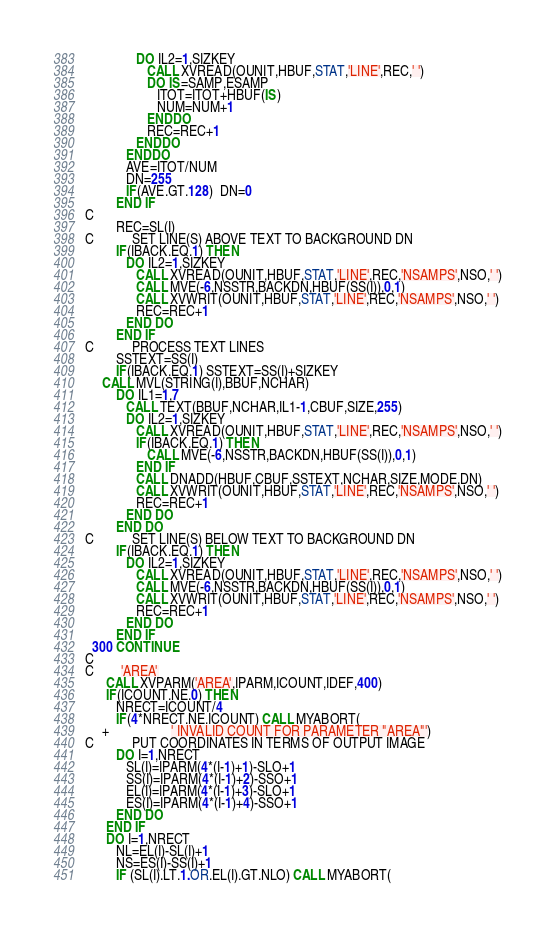<code> <loc_0><loc_0><loc_500><loc_500><_FORTRAN_>               DO IL2=1,SIZKEY
                  CALL XVREAD(OUNIT,HBUF,STAT,'LINE',REC,' ')
                  DO IS=SAMP,ESAMP
                     ITOT=ITOT+HBUF(IS)
                     NUM=NUM+1
                  ENDDO
                  REC=REC+1
               ENDDO
            ENDDO
            AVE=ITOT/NUM
            DN=255
            IF(AVE.GT.128)  DN=0
         END IF
C
         REC=SL(I)
C           SET LINE(S) ABOVE TEXT TO BACKGROUND DN
         IF(IBACK.EQ.1) THEN
            DO IL2=1,SIZKEY
               CALL XVREAD(OUNIT,HBUF,STAT,'LINE',REC,'NSAMPS',NSO,' ')
               CALL MVE(-6,NSSTR,BACKDN,HBUF(SS(I)),0,1)
               CALL XVWRIT(OUNIT,HBUF,STAT,'LINE',REC,'NSAMPS',NSO,' ')
               REC=REC+1
            END DO
         END IF            
C           PROCESS TEXT LINES
         SSTEXT=SS(I)
         IF(IBACK.EQ.1) SSTEXT=SS(I)+SIZKEY
	 CALL MVL(STRING(I),BBUF,NCHAR)
         DO IL1=1,7
            CALL TEXT(BBUF,NCHAR,IL1-1,CBUF,SIZE,255)
            DO IL2=1,SIZKEY
               CALL XVREAD(OUNIT,HBUF,STAT,'LINE',REC,'NSAMPS',NSO,' ')
               IF(IBACK.EQ.1) THEN
                  CALL MVE(-6,NSSTR,BACKDN,HBUF(SS(I)),0,1)
               END IF
               CALL DNADD(HBUF,CBUF,SSTEXT,NCHAR,SIZE,MODE,DN)
               CALL XVWRIT(OUNIT,HBUF,STAT,'LINE',REC,'NSAMPS',NSO,' ')
               REC=REC+1
            END DO
         END DO
C           SET LINE(S) BELOW TEXT TO BACKGROUND DN
         IF(IBACK.EQ.1) THEN
            DO IL2=1,SIZKEY
               CALL XVREAD(OUNIT,HBUF,STAT,'LINE',REC,'NSAMPS',NSO,' ')
               CALL MVE(-6,NSSTR,BACKDN,HBUF(SS(I)),0,1)
               CALL XVWRIT(OUNIT,HBUF,STAT,'LINE',REC,'NSAMPS',NSO,' ')
               REC=REC+1
            END DO
         END IF            
  300 CONTINUE
C
C        'AREA'
      CALL XVPARM('AREA',IPARM,ICOUNT,IDEF,400)
      IF(ICOUNT.NE.0) THEN
         NRECT=ICOUNT/4
         IF(4*NRECT.NE.ICOUNT) CALL MYABORT(
     +				  ' INVALID COUNT FOR PARAMETER "AREA"')
C           PUT COORDINATES IN TERMS OF OUTPUT IMAGE 
         DO I=1,NRECT
            SL(I)=IPARM(4*(I-1)+1)-SLO+1
            SS(I)=IPARM(4*(I-1)+2)-SSO+1
            EL(I)=IPARM(4*(I-1)+3)-SLO+1
            ES(I)=IPARM(4*(I-1)+4)-SSO+1
         END DO
      END IF
      DO I=1,NRECT
         NL=EL(I)-SL(I)+1
         NS=ES(I)-SS(I)+1
         IF (SL(I).LT.1.OR.EL(I).GT.NLO) CALL MYABORT(</code> 